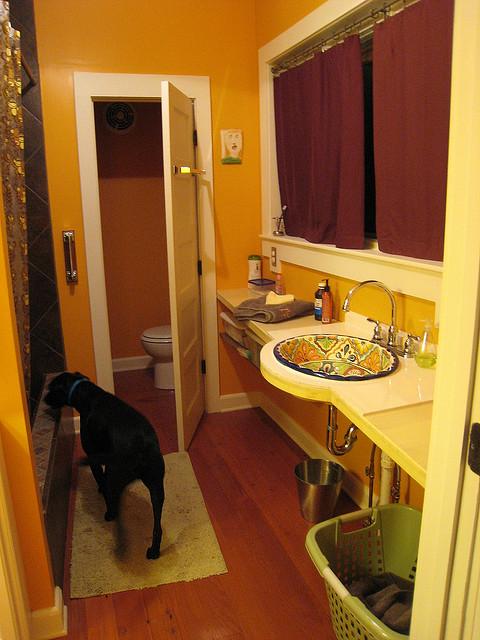What color is the dog?
Concise answer only. Black. What color is the basket under the counter?
Quick response, please. Green. What room is this?
Be succinct. Bathroom. What animal is pictured?
Write a very short answer. Dog. 